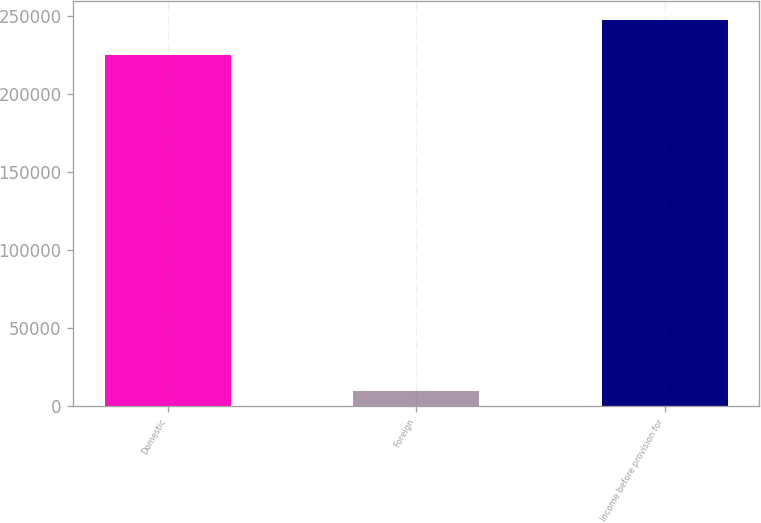<chart> <loc_0><loc_0><loc_500><loc_500><bar_chart><fcel>Domestic<fcel>Foreign<fcel>Income before provision for<nl><fcel>225079<fcel>9456<fcel>247587<nl></chart> 